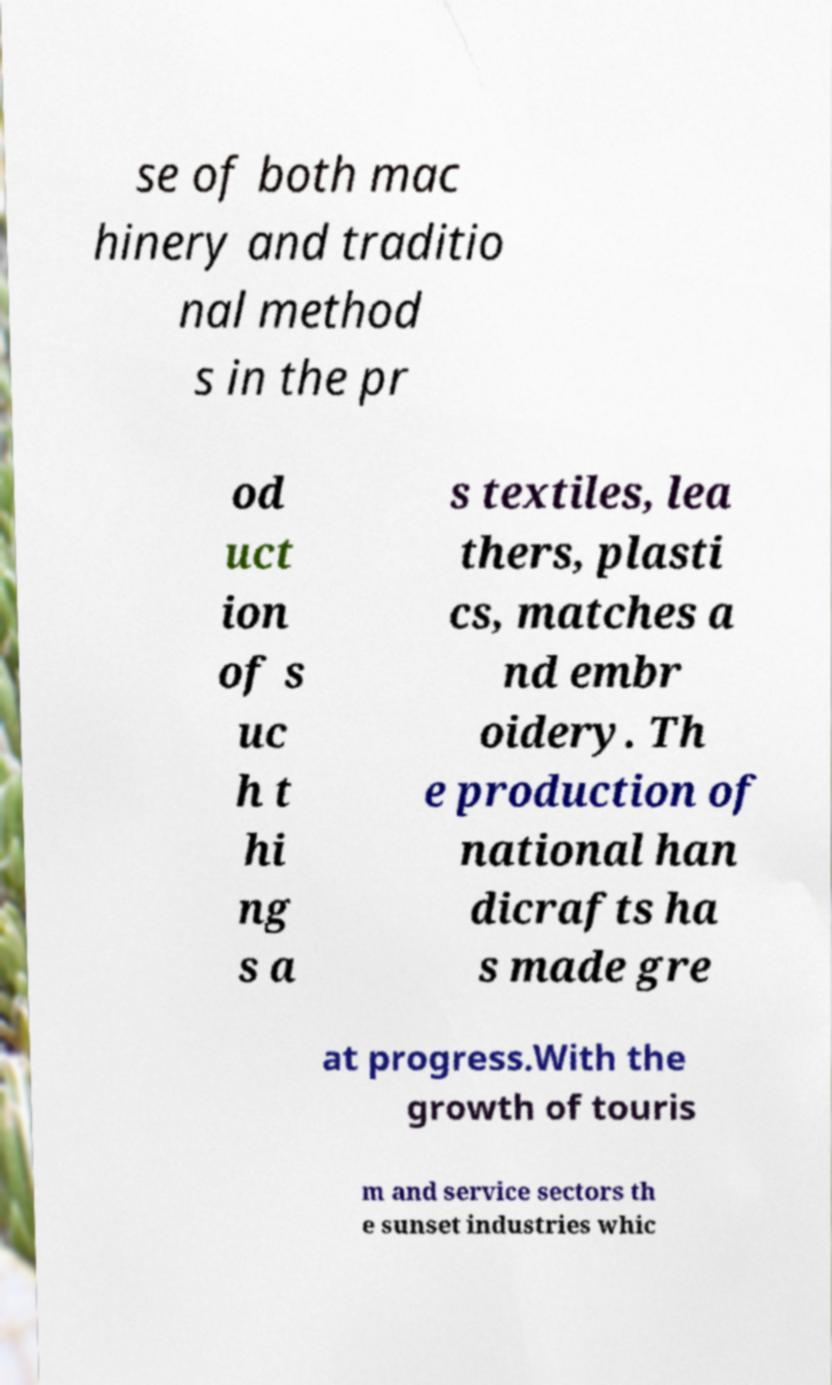Could you extract and type out the text from this image? se of both mac hinery and traditio nal method s in the pr od uct ion of s uc h t hi ng s a s textiles, lea thers, plasti cs, matches a nd embr oidery. Th e production of national han dicrafts ha s made gre at progress.With the growth of touris m and service sectors th e sunset industries whic 